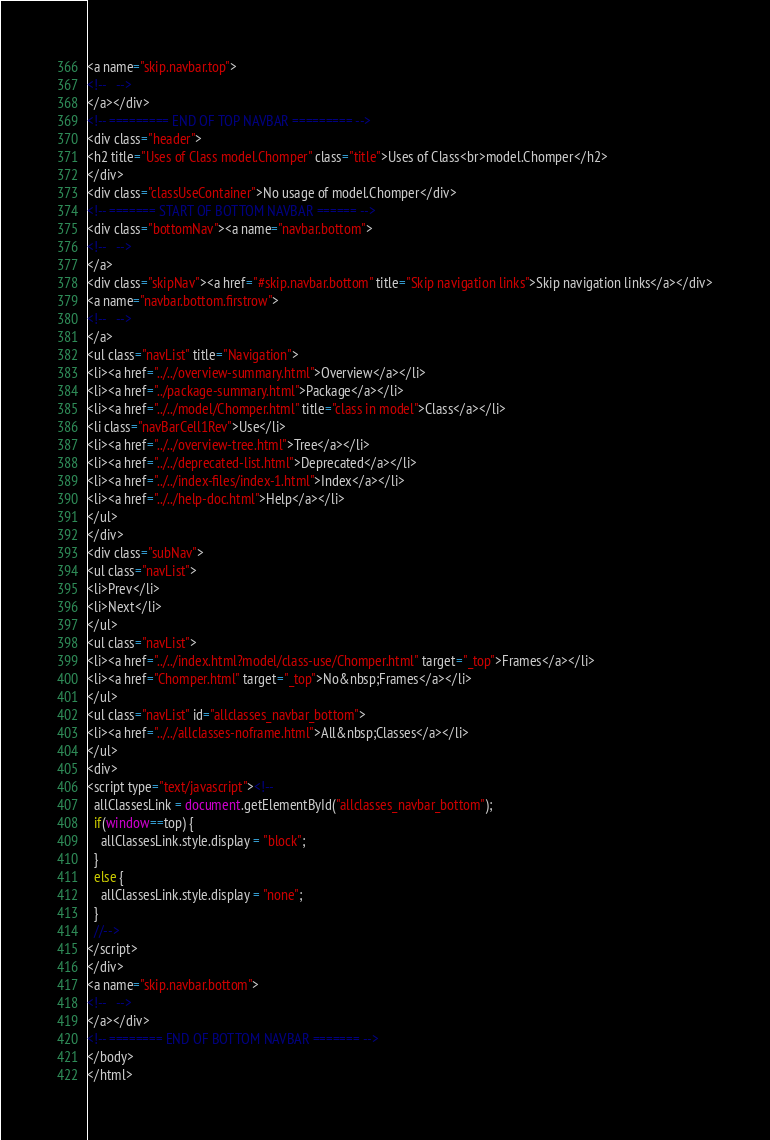<code> <loc_0><loc_0><loc_500><loc_500><_HTML_><a name="skip.navbar.top">
<!--   -->
</a></div>
<!-- ========= END OF TOP NAVBAR ========= -->
<div class="header">
<h2 title="Uses of Class model.Chomper" class="title">Uses of Class<br>model.Chomper</h2>
</div>
<div class="classUseContainer">No usage of model.Chomper</div>
<!-- ======= START OF BOTTOM NAVBAR ====== -->
<div class="bottomNav"><a name="navbar.bottom">
<!--   -->
</a>
<div class="skipNav"><a href="#skip.navbar.bottom" title="Skip navigation links">Skip navigation links</a></div>
<a name="navbar.bottom.firstrow">
<!--   -->
</a>
<ul class="navList" title="Navigation">
<li><a href="../../overview-summary.html">Overview</a></li>
<li><a href="../package-summary.html">Package</a></li>
<li><a href="../../model/Chomper.html" title="class in model">Class</a></li>
<li class="navBarCell1Rev">Use</li>
<li><a href="../../overview-tree.html">Tree</a></li>
<li><a href="../../deprecated-list.html">Deprecated</a></li>
<li><a href="../../index-files/index-1.html">Index</a></li>
<li><a href="../../help-doc.html">Help</a></li>
</ul>
</div>
<div class="subNav">
<ul class="navList">
<li>Prev</li>
<li>Next</li>
</ul>
<ul class="navList">
<li><a href="../../index.html?model/class-use/Chomper.html" target="_top">Frames</a></li>
<li><a href="Chomper.html" target="_top">No&nbsp;Frames</a></li>
</ul>
<ul class="navList" id="allclasses_navbar_bottom">
<li><a href="../../allclasses-noframe.html">All&nbsp;Classes</a></li>
</ul>
<div>
<script type="text/javascript"><!--
  allClassesLink = document.getElementById("allclasses_navbar_bottom");
  if(window==top) {
    allClassesLink.style.display = "block";
  }
  else {
    allClassesLink.style.display = "none";
  }
  //-->
</script>
</div>
<a name="skip.navbar.bottom">
<!--   -->
</a></div>
<!-- ======== END OF BOTTOM NAVBAR ======= -->
</body>
</html>
</code> 